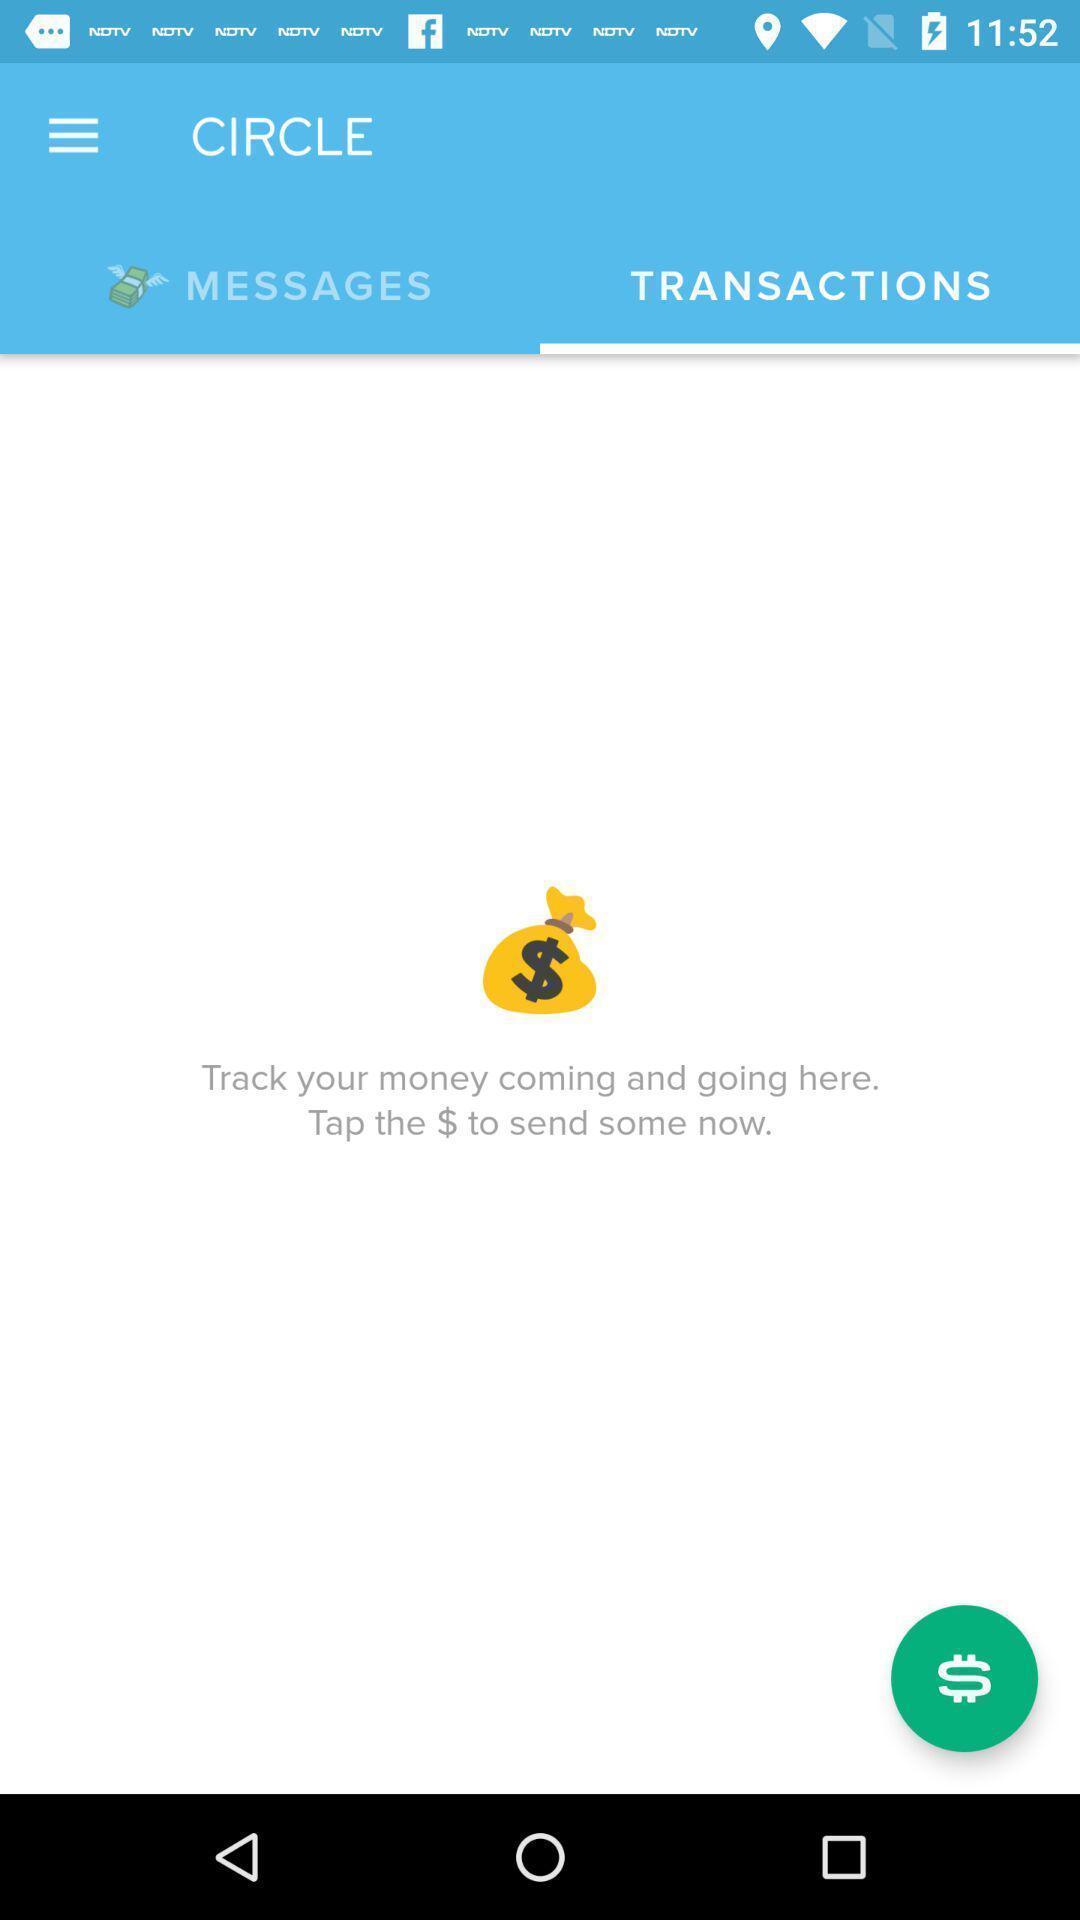Explain the elements present in this screenshot. Page to find the transactions for app. 